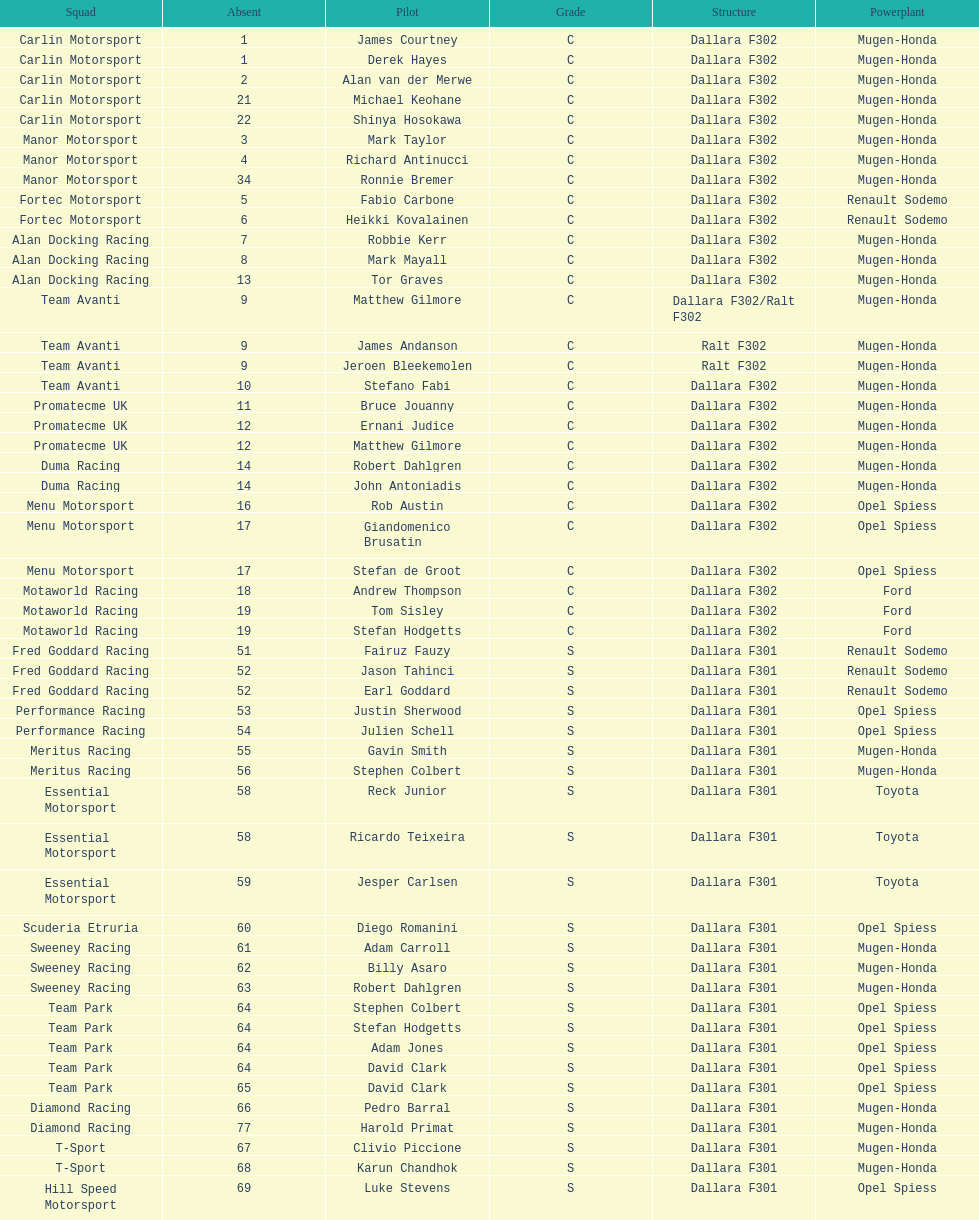What is the average number of teams that had a mugen-honda engine? 24. 